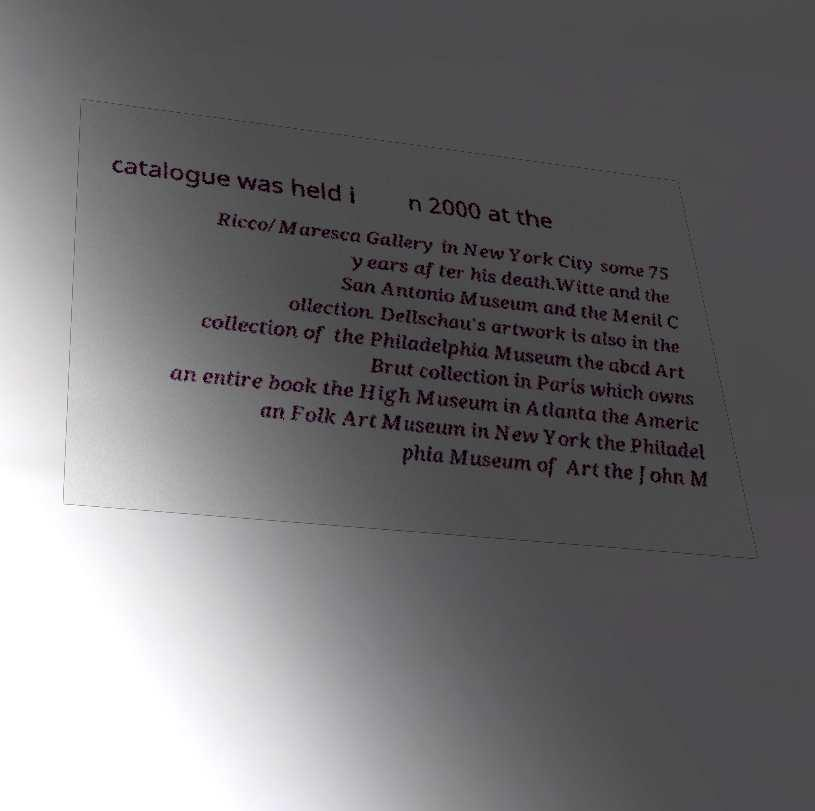Please read and relay the text visible in this image. What does it say? catalogue was held i n 2000 at the Ricco/Maresca Gallery in New York City some 75 years after his death.Witte and the San Antonio Museum and the Menil C ollection. Dellschau's artwork is also in the collection of the Philadelphia Museum the abcd Art Brut collection in Paris which owns an entire book the High Museum in Atlanta the Americ an Folk Art Museum in New York the Philadel phia Museum of Art the John M 